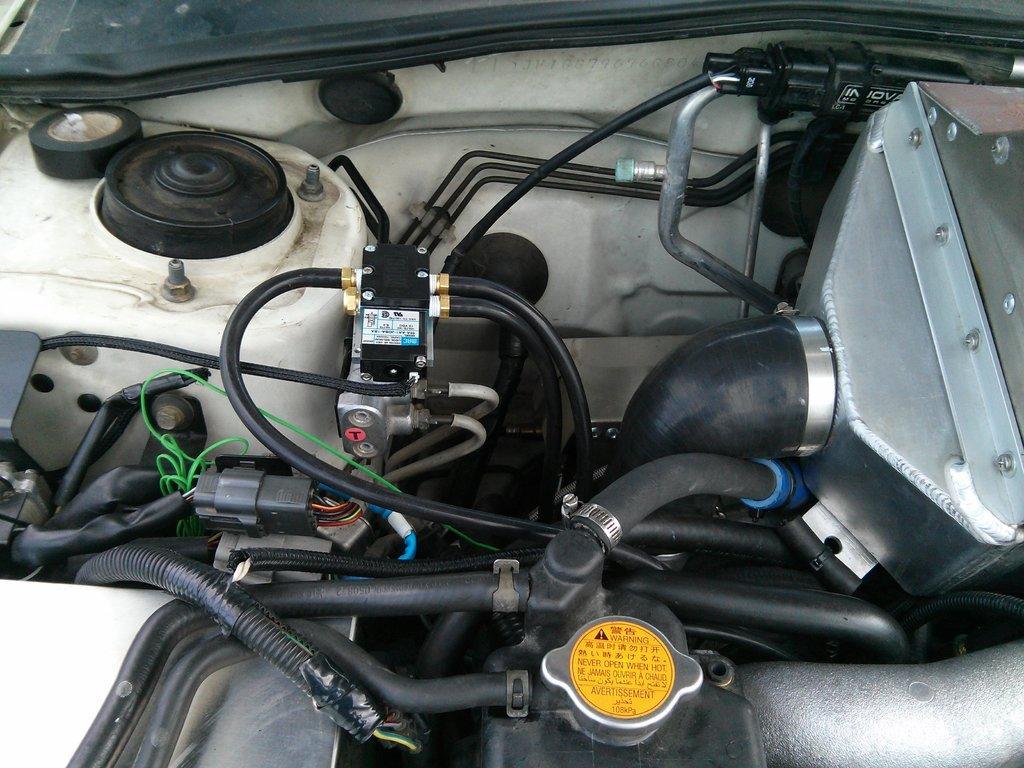In one or two sentences, can you explain what this image depicts? In this image, we can see engine, pipes, rods, cables and few objects. On the left side top of the image, we can see tape. 